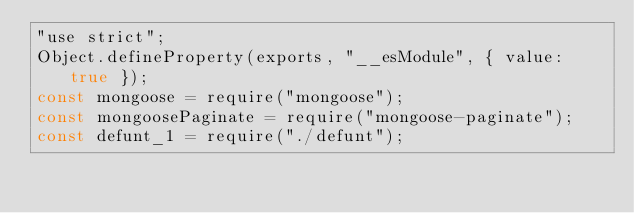<code> <loc_0><loc_0><loc_500><loc_500><_JavaScript_>"use strict";
Object.defineProperty(exports, "__esModule", { value: true });
const mongoose = require("mongoose");
const mongoosePaginate = require("mongoose-paginate");
const defunt_1 = require("./defunt");</code> 